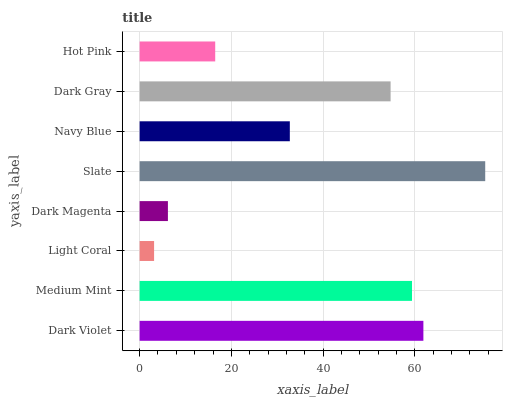Is Light Coral the minimum?
Answer yes or no. Yes. Is Slate the maximum?
Answer yes or no. Yes. Is Medium Mint the minimum?
Answer yes or no. No. Is Medium Mint the maximum?
Answer yes or no. No. Is Dark Violet greater than Medium Mint?
Answer yes or no. Yes. Is Medium Mint less than Dark Violet?
Answer yes or no. Yes. Is Medium Mint greater than Dark Violet?
Answer yes or no. No. Is Dark Violet less than Medium Mint?
Answer yes or no. No. Is Dark Gray the high median?
Answer yes or no. Yes. Is Navy Blue the low median?
Answer yes or no. Yes. Is Dark Magenta the high median?
Answer yes or no. No. Is Slate the low median?
Answer yes or no. No. 